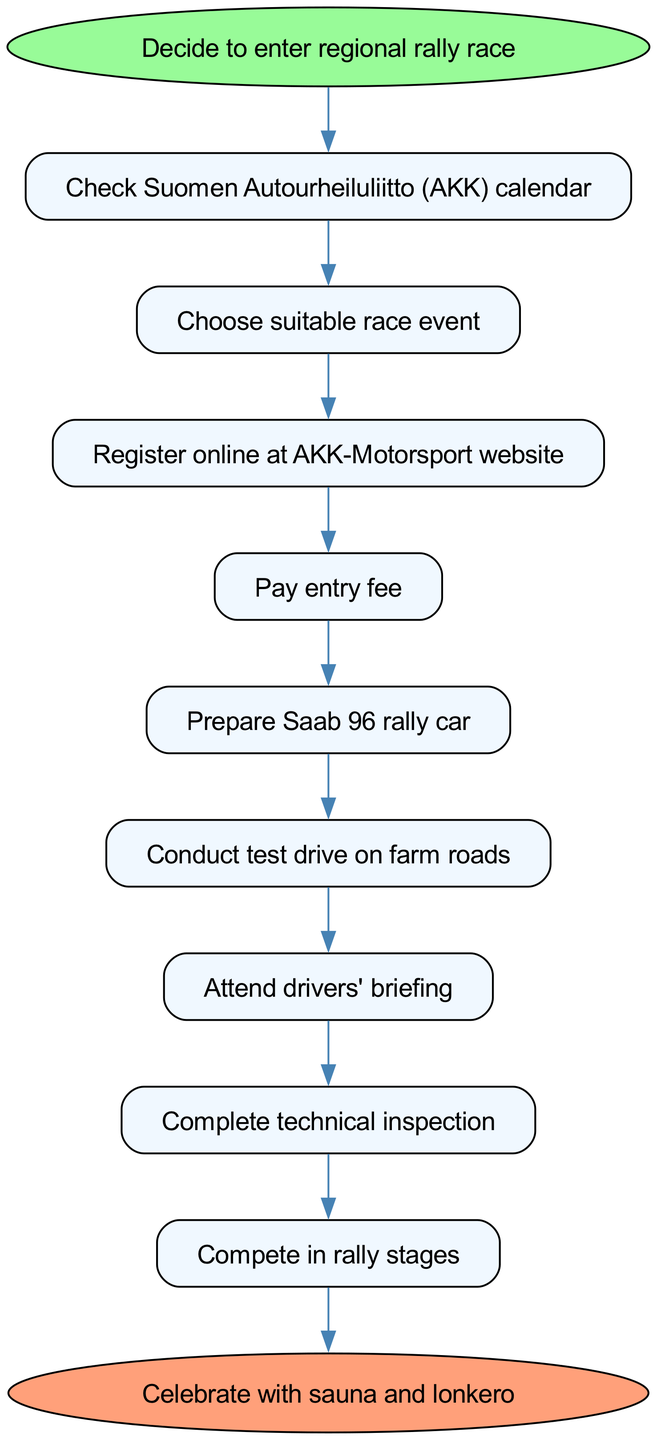What is the starting action in the workflow? The workflow starts with the action to "Decide to enter regional rally race." This is the first step before any subsequent actions can take place.
Answer: Decide to enter regional rally race What is the last action before celebrating? The last action before celebrating is "Finish race and collect results." This indicates that all prior steps lead to this outcome, which is essential before any celebration.
Answer: Finish race and collect results How many steps are there in total? There are nine distinct steps in the workflow listed before the final celebration action. Each step contributes to the overall process from beginning to end.
Answer: Nine What action follows after preparing the Saab 96 rally car? After "Prepare Saab 96 rally car," the next action is "Conduct test drive on farm roads.” This shows a sequential flow from preparing the vehicle to testing it.
Answer: Conduct test drive on farm roads Which step requires making an online registration? The step that involves online registration is "Register online at AKK-Motorsport website." This step directly addresses the registration process necessary for participating in the rally.
Answer: Register online at AKK-Motorsport website What is the relationship between "Attend drivers' briefing" and "Complete technical inspection"? "Attend drivers' briefing" must occur before "Complete technical inspection." This order indicates that drivers need to be informed before their vehicles can be technically approved.
Answer: Attend drivers' briefing What is the first action that requires payment? The first action that requires payment is "Pay entry fee." This is a crucial financial step that follows the online registration process in the workflow.
Answer: Pay entry fee Which two steps are directly connected by an edge? "Conduct test drive on farm roads" and "Attend drivers' briefing" are directly connected by an edge. This shows a direct sequence of actions where one leads to the next in the workflow.
Answer: Conduct test drive on farm roads, Attend drivers' briefing What action directly leads to competing in rally stages? The action that directly leads to "Compete in rally stages" is "Complete technical inspection." Passing the technical inspection enables participation in the competition.
Answer: Complete technical inspection 